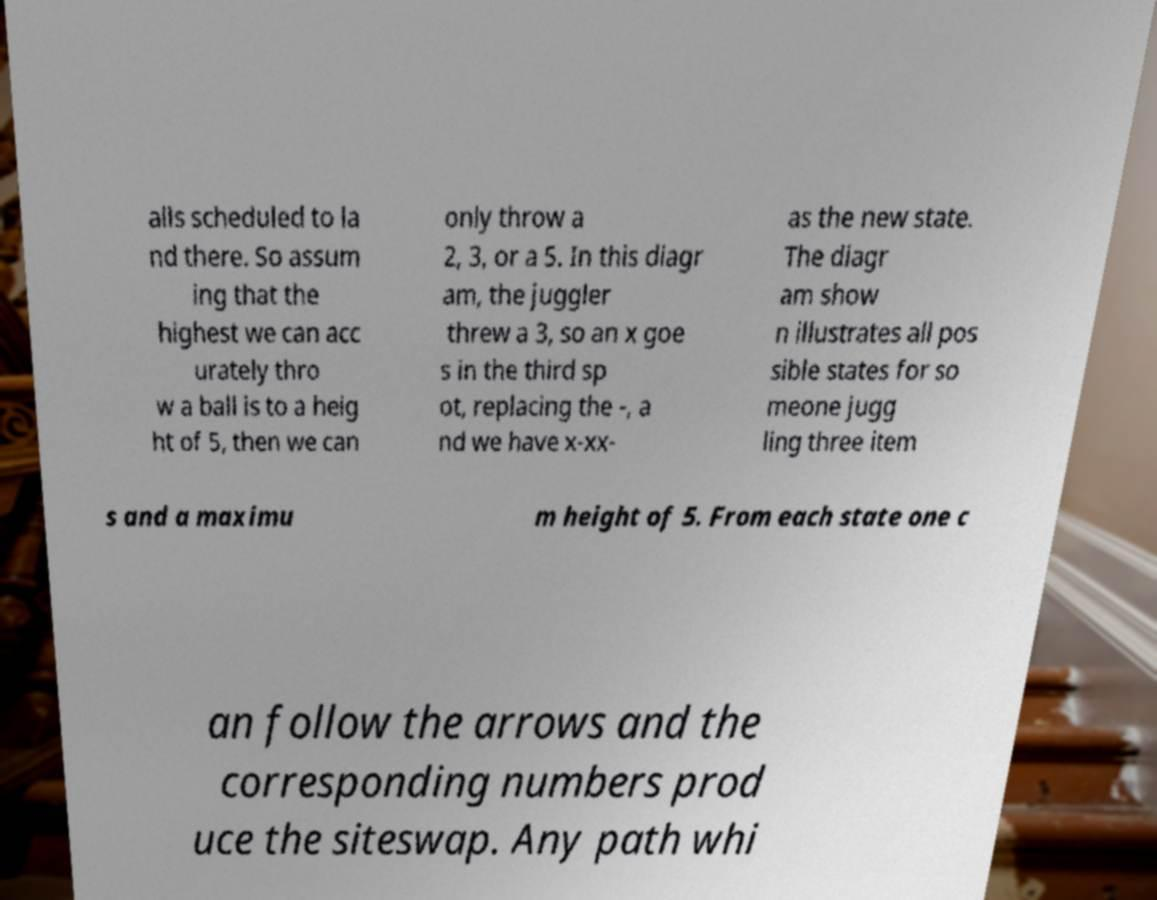Can you read and provide the text displayed in the image?This photo seems to have some interesting text. Can you extract and type it out for me? alls scheduled to la nd there. So assum ing that the highest we can acc urately thro w a ball is to a heig ht of 5, then we can only throw a 2, 3, or a 5. In this diagr am, the juggler threw a 3, so an x goe s in the third sp ot, replacing the -, a nd we have x-xx- as the new state. The diagr am show n illustrates all pos sible states for so meone jugg ling three item s and a maximu m height of 5. From each state one c an follow the arrows and the corresponding numbers prod uce the siteswap. Any path whi 